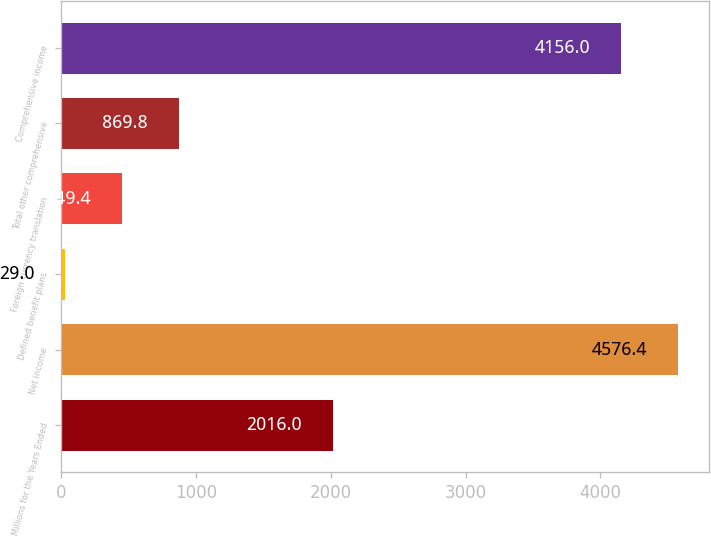Convert chart to OTSL. <chart><loc_0><loc_0><loc_500><loc_500><bar_chart><fcel>Millions for the Years Ended<fcel>Net income<fcel>Defined benefit plans<fcel>Foreign currency translation<fcel>Total other comprehensive<fcel>Comprehensive income<nl><fcel>2016<fcel>4576.4<fcel>29<fcel>449.4<fcel>869.8<fcel>4156<nl></chart> 